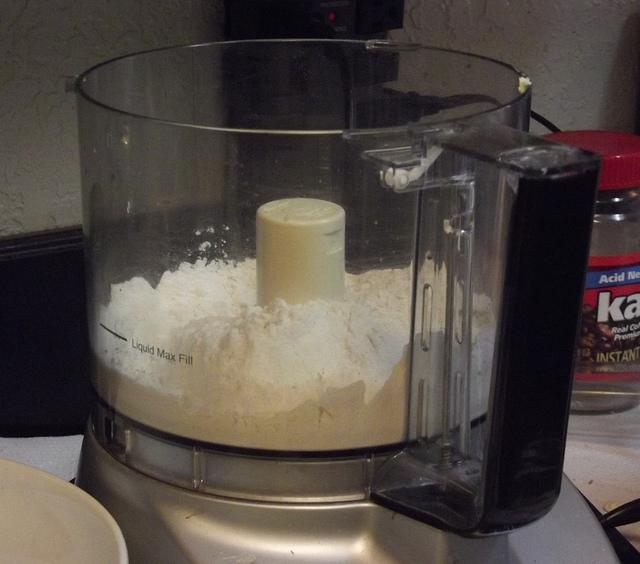What is in that pitcher?
Write a very short answer. Flour. What appliance is being used in the pot?
Be succinct. Blender. Are they making a smoothie?
Give a very brief answer. No. What material are these containers made of?
Be succinct. Plastic. What is the quantity that fits in this blender?
Keep it brief. 4 cups. What is the person going to make?
Be succinct. Cake. What else should go into the blender?
Short answer required. Butter. What is in the mixer?
Write a very short answer. Flour. What appliance is this?
Keep it brief. Food processor. What color is the mixer's handle?
Short answer required. Black. What is this?
Be succinct. Food processor. What is the brand name of the blender?
Answer briefly. Liquid max. 